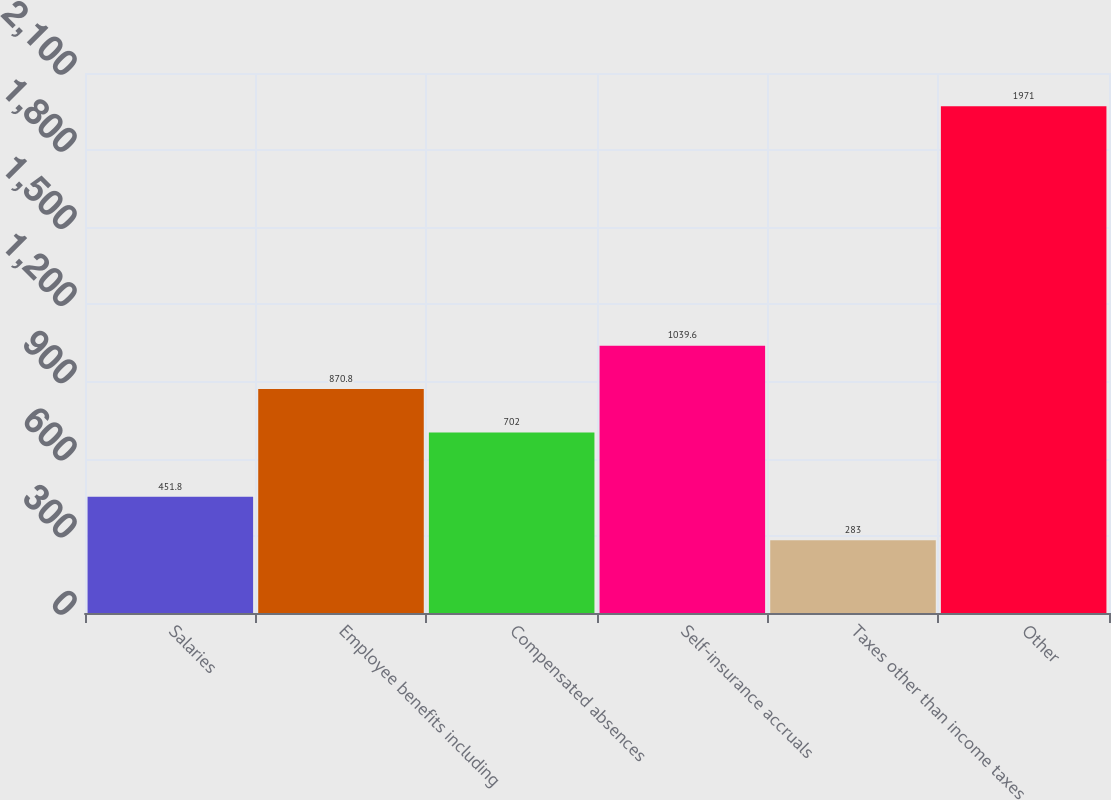Convert chart. <chart><loc_0><loc_0><loc_500><loc_500><bar_chart><fcel>Salaries<fcel>Employee benefits including<fcel>Compensated absences<fcel>Self-insurance accruals<fcel>Taxes other than income taxes<fcel>Other<nl><fcel>451.8<fcel>870.8<fcel>702<fcel>1039.6<fcel>283<fcel>1971<nl></chart> 